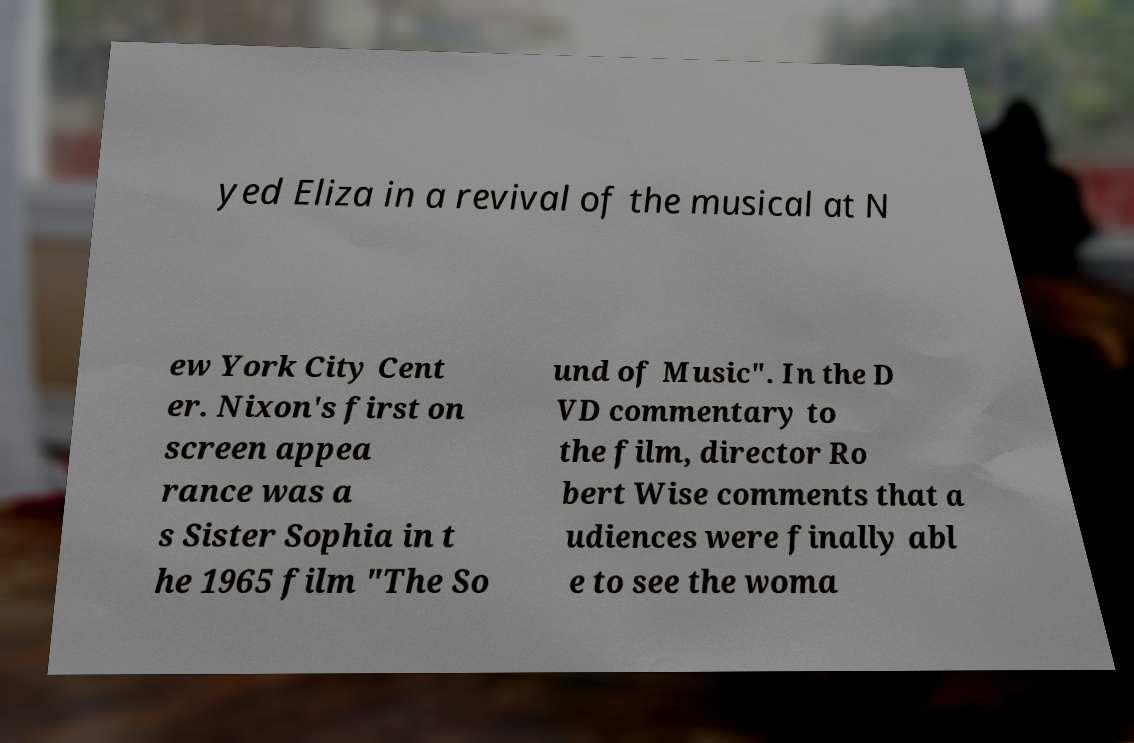I need the written content from this picture converted into text. Can you do that? yed Eliza in a revival of the musical at N ew York City Cent er. Nixon's first on screen appea rance was a s Sister Sophia in t he 1965 film "The So und of Music". In the D VD commentary to the film, director Ro bert Wise comments that a udiences were finally abl e to see the woma 